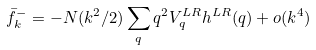<formula> <loc_0><loc_0><loc_500><loc_500>\bar { f } _ { k } ^ { - } = - N ( k ^ { 2 } / 2 ) \sum _ { q } q ^ { 2 } V _ { q } ^ { L R } h ^ { L R } ( q ) + o ( k ^ { 4 } )</formula> 